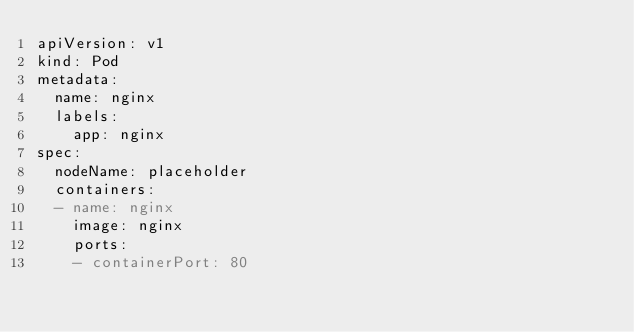<code> <loc_0><loc_0><loc_500><loc_500><_YAML_>apiVersion: v1
kind: Pod
metadata:
  name: nginx
  labels:
    app: nginx
spec:
  nodeName: placeholder
  containers:
  - name: nginx
    image: nginx
    ports:
    - containerPort: 80
</code> 